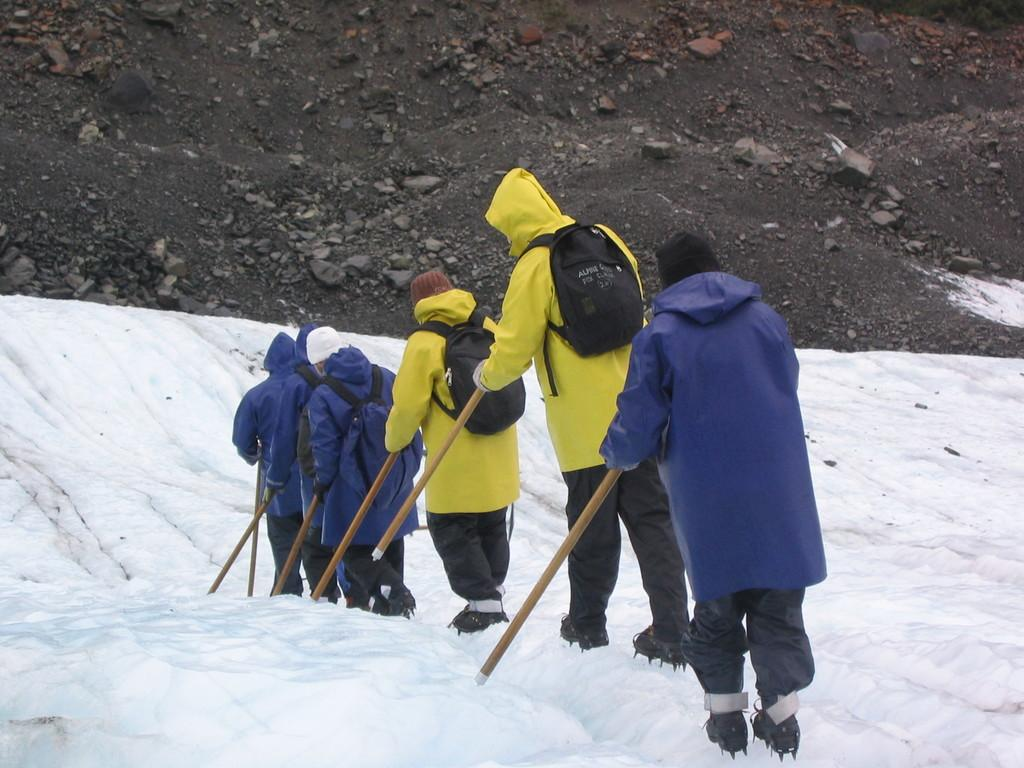Who is present in the image? There are people in the image. What are the people wearing? The people are wearing jackets. What is the terrain like in the image? The people are walking on snow. What objects are the people holding in their hands? The people are holding sticks in their hands. What are the people carrying on their backs? The people are carrying backpacks. What type of coach can be seen in the image? There is no coach present in the image. What type of camp is visible in the image? There is no camp present in the image. 